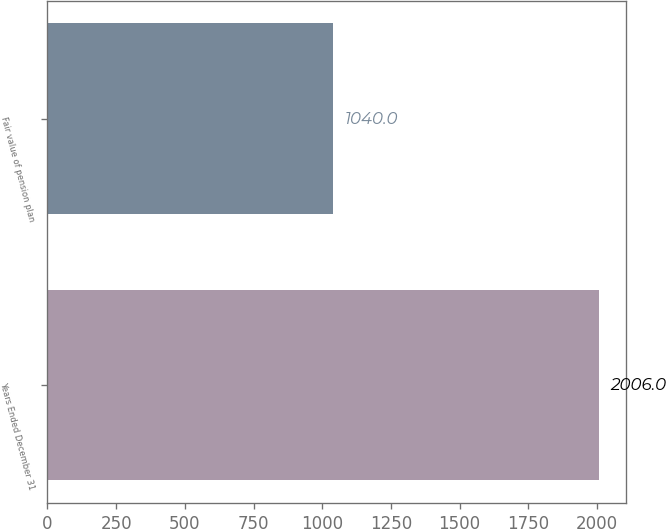Convert chart to OTSL. <chart><loc_0><loc_0><loc_500><loc_500><bar_chart><fcel>Years Ended December 31<fcel>Fair value of pension plan<nl><fcel>2006<fcel>1040<nl></chart> 